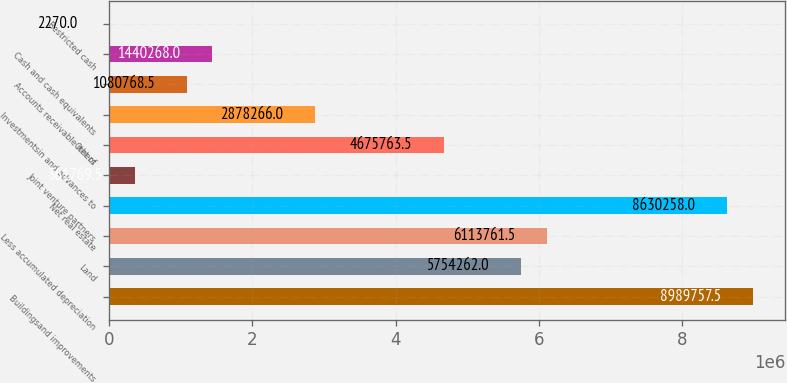<chart> <loc_0><loc_0><loc_500><loc_500><bar_chart><fcel>Buildingsand improvements<fcel>Land<fcel>Less accumulated depreciation<fcel>Net real estate<fcel>Joint venture partners<fcel>Others<fcel>Investmentsin and advances to<fcel>Accounts receivable net of<fcel>Cash and cash equivalents<fcel>Restricted cash<nl><fcel>8.98976e+06<fcel>5.75426e+06<fcel>6.11376e+06<fcel>8.63026e+06<fcel>361770<fcel>4.67576e+06<fcel>2.87827e+06<fcel>1.08077e+06<fcel>1.44027e+06<fcel>2270<nl></chart> 